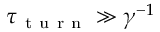Convert formula to latex. <formula><loc_0><loc_0><loc_500><loc_500>\tau _ { t u r n } \gg \gamma ^ { - 1 }</formula> 